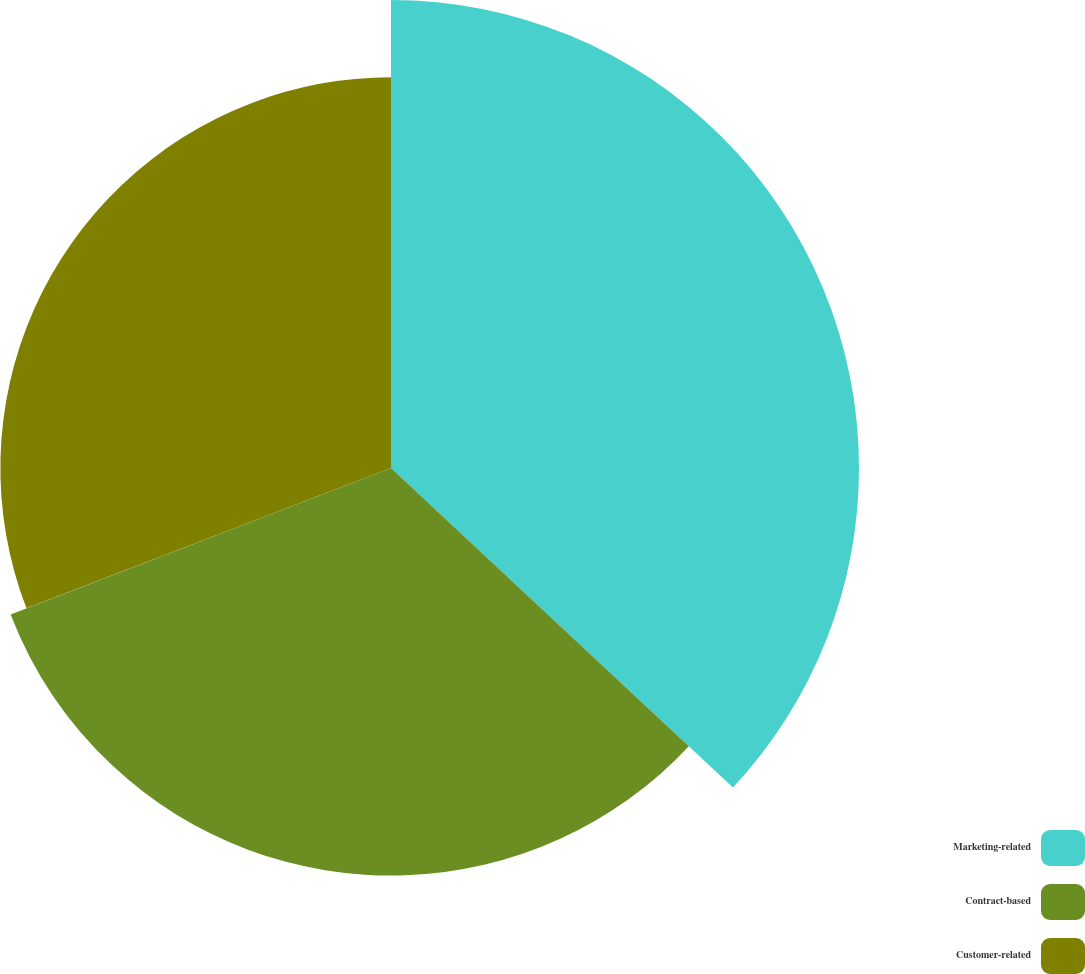<chart> <loc_0><loc_0><loc_500><loc_500><pie_chart><fcel>Marketing-related<fcel>Contract-based<fcel>Customer-related<nl><fcel>36.96%<fcel>32.19%<fcel>30.85%<nl></chart> 